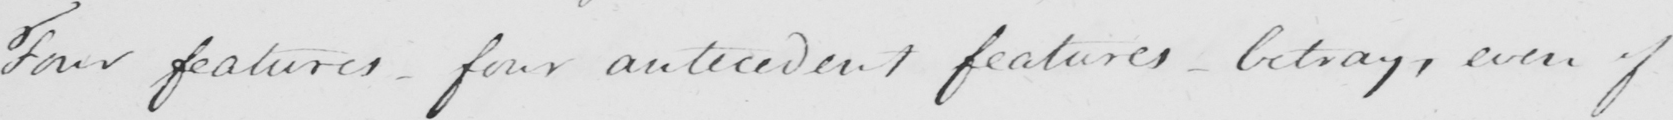Can you read and transcribe this handwriting? Four features  _  four antecedent features  _  betray , even of 